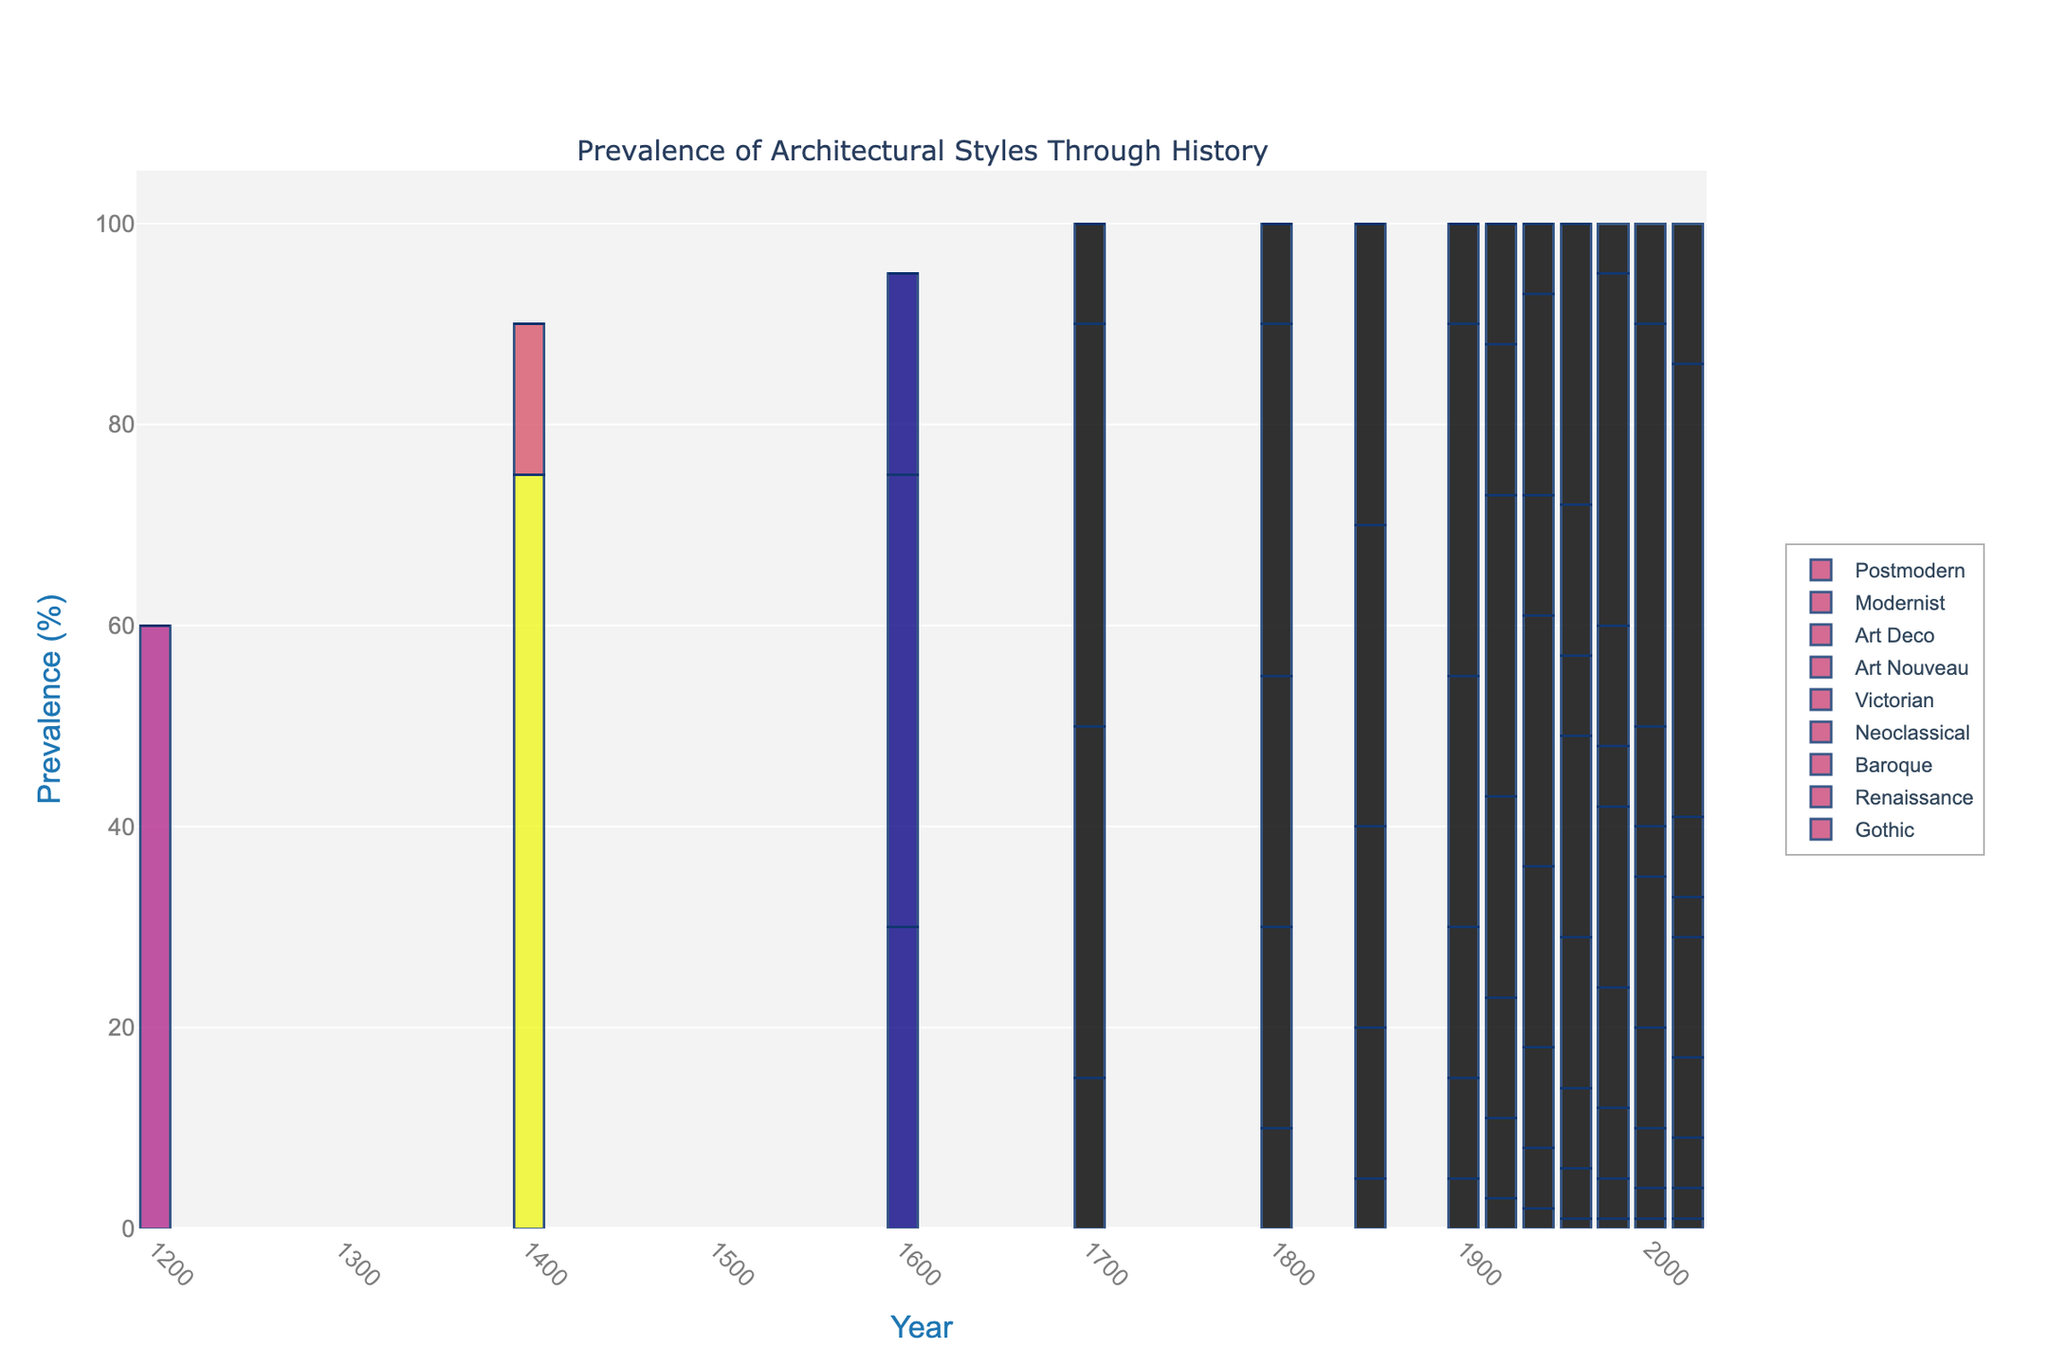What's the most prevalent architectural style in the year 1600? Observe the bar heights for the year 1600 in the bar chart. The Renaissance style has the tallest bar, indicating its prevalence.
Answer: Renaissance How does the prevalence of Gothic architecture change from 1400 to 1600? Look at the bar heights for Gothic architecture in the years 1400 and 1600. It decreases from 75% in 1400 to 30% in 1600.
Answer: Decreases By how much does the prevalence of Victorian architecture increase from 1800 to 1850? Identify the Victorian architecture bars in the years 1800 and 1850. The prevalence increases from 10% to 30%. The difference is 30% - 10% = 20%.
Answer: 20% Which architectural style becomes more prevalent between 1920 and 1940: Art Deco or Modernist? Compare the heights of the Art Deco and Modernist bars in 1920 and 1940. The Art Deco bar rises from 12% to 20%, while the Modernist bar rises from 0% to 7%. Thus, Art Deco increases more.
Answer: Art Deco What is the combined prevalence of all architectural styles in the year 2000? Sum the bar heights for all architectural styles in the year 2000: Gothic (1) + Renaissance (3) + Baroque (6) + Neoclassical (10) + Victorian (15) + Art Nouveau (5) + Art Deco (10) + Modernist (40) + Postmodern (10) = 100%.
Answer: 100% How does the trend of Neoclassical architecture change from 1700 to 1900? Observe the bar heights for Neoclassical architecture from 1700 to 1900. It starts at 10% in 1700, increases to 35% in 1800, remains at 30% in 1850, then drops to 25% in 1900. The overall trend is upward initially and then slightly down.
Answer: Increases then decreases Which style has the sharpest decline in prevalence from the 1400s to the 2000s? Compare the bar heights of various architectural styles from 1400 to 2000. Gothic declines from 75% in 1400 to 1% in 2000, marking a sharp decline.
Answer: Gothic Between which two consecutive time periods does Modernist architecture show the highest increase? Examine the bar heights for Modernist architecture across all periods. The highest increase is between 1960 (28%) and 1980 (35%), an increase of 7%.
Answer: 1960 to 1980 Comparatively, how many percent more prevalent is Art Nouveau in 1920 than in 1940? Look at the bar heights for Art Nouveau in 1920 (15%) and 1940 (12%). To find the difference: 15% - 12% = 3%. Then, since it is less prevalent in 1940, 3% more prevalent in 1920.
Answer: 3% What is the average prevalence of Renaissance architecture from 1600 to 1800? Add the prevalences for Renaissance in the years 1600, 1700, and 1800 and divide by 3: (45 + 35 + 20) / 3 = 100 / 3 ≈ 33.33%.
Answer: Approx. 33.33% 